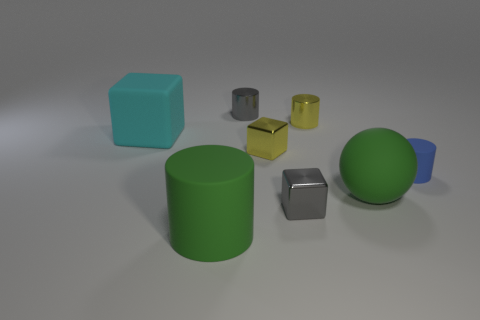Is there a matte cylinder that has the same color as the big sphere?
Offer a very short reply. Yes. Are the large cylinder and the cyan cube made of the same material?
Your answer should be compact. Yes. How many green things are behind the yellow cube?
Your answer should be very brief. 0. What material is the cylinder that is both right of the small yellow metallic cube and in front of the small yellow metallic block?
Keep it short and to the point. Rubber. What number of green matte cylinders are the same size as the cyan matte thing?
Offer a terse response. 1. What is the color of the big matte object in front of the large green object behind the green matte cylinder?
Give a very brief answer. Green. Is there a tiny yellow shiny object?
Make the answer very short. Yes. Do the big cyan object and the tiny blue rubber object have the same shape?
Your answer should be very brief. No. What size is the rubber sphere that is the same color as the large matte cylinder?
Offer a very short reply. Large. How many cylinders are on the left side of the small gray thing in front of the blue object?
Provide a succinct answer. 2. 